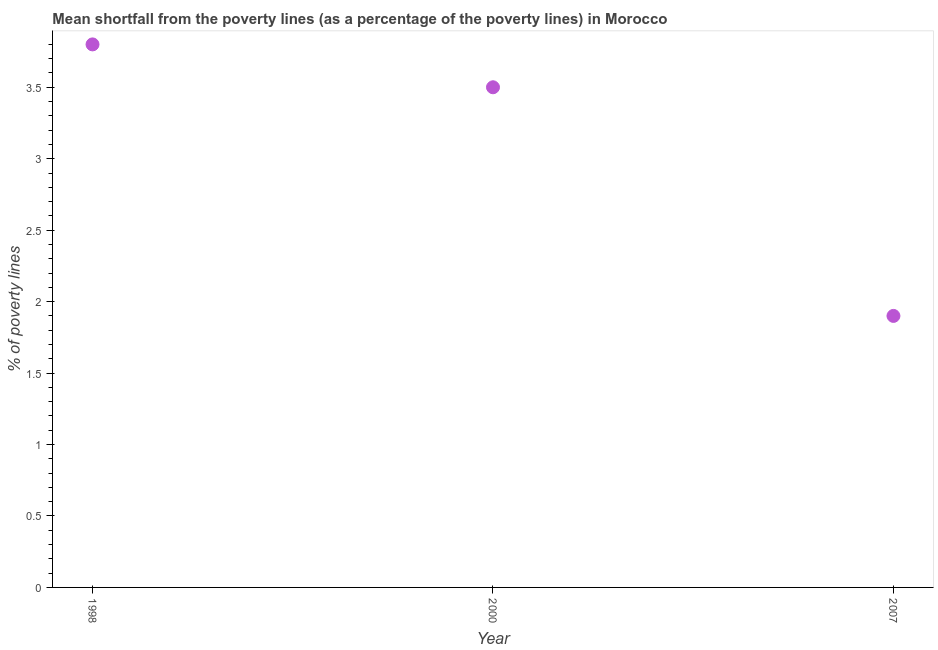What is the poverty gap at national poverty lines in 2000?
Ensure brevity in your answer.  3.5. In which year was the poverty gap at national poverty lines minimum?
Keep it short and to the point. 2007. What is the sum of the poverty gap at national poverty lines?
Keep it short and to the point. 9.2. What is the difference between the poverty gap at national poverty lines in 2000 and 2007?
Your response must be concise. 1.6. What is the average poverty gap at national poverty lines per year?
Your answer should be very brief. 3.07. Is the poverty gap at national poverty lines in 1998 less than that in 2000?
Keep it short and to the point. No. Is the difference between the poverty gap at national poverty lines in 2000 and 2007 greater than the difference between any two years?
Ensure brevity in your answer.  No. What is the difference between the highest and the second highest poverty gap at national poverty lines?
Make the answer very short. 0.3. Is the sum of the poverty gap at national poverty lines in 2000 and 2007 greater than the maximum poverty gap at national poverty lines across all years?
Keep it short and to the point. Yes. What is the difference between two consecutive major ticks on the Y-axis?
Offer a terse response. 0.5. Are the values on the major ticks of Y-axis written in scientific E-notation?
Make the answer very short. No. What is the title of the graph?
Your answer should be compact. Mean shortfall from the poverty lines (as a percentage of the poverty lines) in Morocco. What is the label or title of the Y-axis?
Offer a terse response. % of poverty lines. What is the % of poverty lines in 2007?
Make the answer very short. 1.9. What is the difference between the % of poverty lines in 1998 and 2000?
Offer a very short reply. 0.3. What is the difference between the % of poverty lines in 2000 and 2007?
Make the answer very short. 1.6. What is the ratio of the % of poverty lines in 1998 to that in 2000?
Make the answer very short. 1.09. What is the ratio of the % of poverty lines in 2000 to that in 2007?
Offer a very short reply. 1.84. 